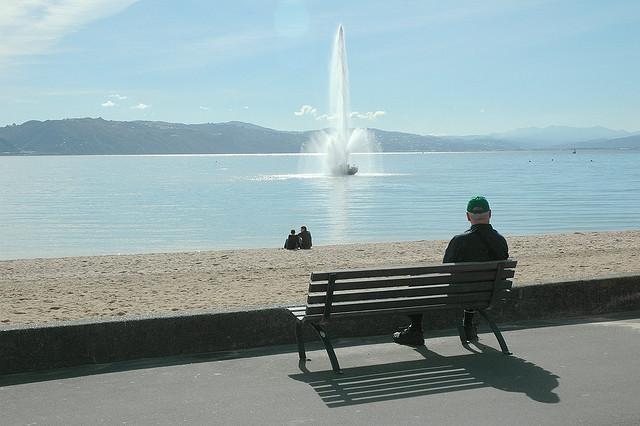How many people are sitting at the water edge?
Give a very brief answer. 2. How many benches are on the beach?
Give a very brief answer. 1. How many living creatures are present?
Give a very brief answer. 3. How many of the people on the closest bench are talking?
Give a very brief answer. 0. 